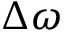Convert formula to latex. <formula><loc_0><loc_0><loc_500><loc_500>\Delta \omega</formula> 